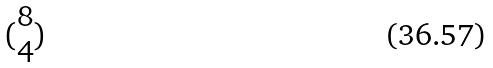<formula> <loc_0><loc_0><loc_500><loc_500>( \begin{matrix} 8 \\ 4 \end{matrix} )</formula> 